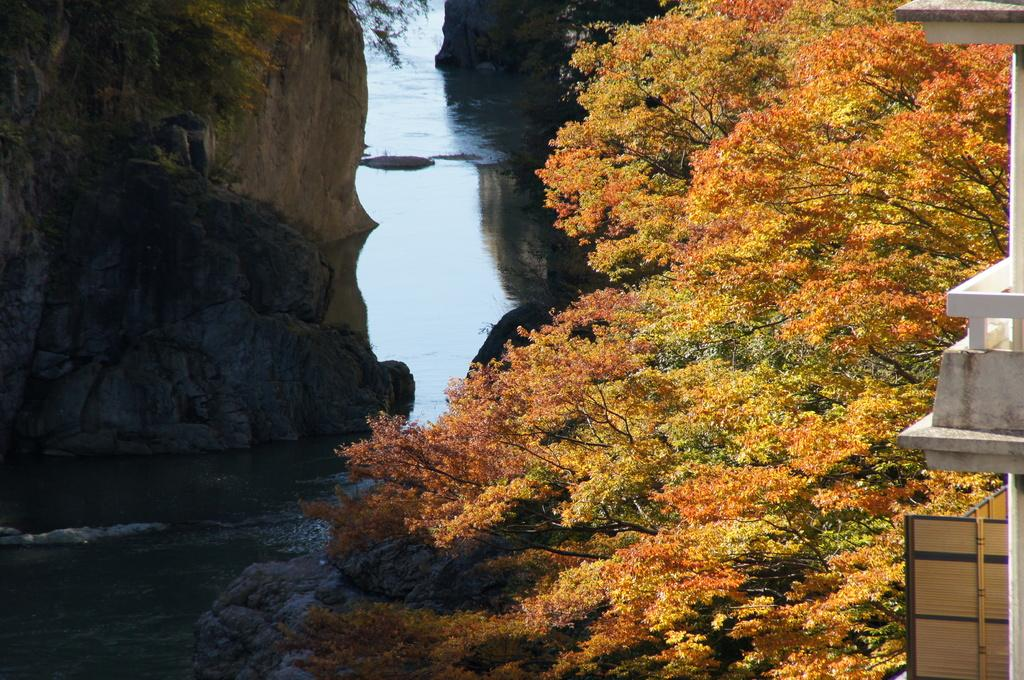What is located in the foreground of the image? There is a tree and a building in the foreground of the image. What can be seen in the middle of the image? There is water in the middle of the image. What is visible in the background of the image? There are mountains visible in the background of the image. What type of tools does the carpenter have in the image? There is no carpenter present in the image. What does the bottle contain in the image? There is no bottle present in the image. 